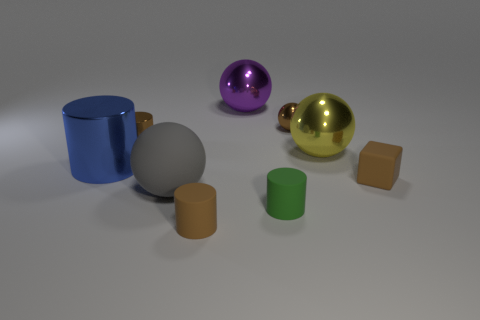Is the size of the gray ball the same as the brown matte object that is in front of the green object?
Your answer should be very brief. No. Is the size of the purple metal thing the same as the yellow metal thing?
Ensure brevity in your answer.  Yes. Are there any cyan rubber objects of the same size as the purple metal ball?
Your answer should be compact. No. What is the brown cylinder to the right of the gray matte object made of?
Keep it short and to the point. Rubber. There is a large thing that is the same material as the cube; what is its color?
Your response must be concise. Gray. How many metallic objects are either balls or tiny yellow blocks?
Your answer should be compact. 3. The green matte thing that is the same size as the brown matte block is what shape?
Keep it short and to the point. Cylinder. What number of objects are either small brown things on the right side of the brown metal cylinder or large balls behind the blue object?
Your response must be concise. 5. There is a blue cylinder that is the same size as the yellow metallic thing; what material is it?
Provide a short and direct response. Metal. What number of other objects are there of the same material as the big blue cylinder?
Keep it short and to the point. 4. 